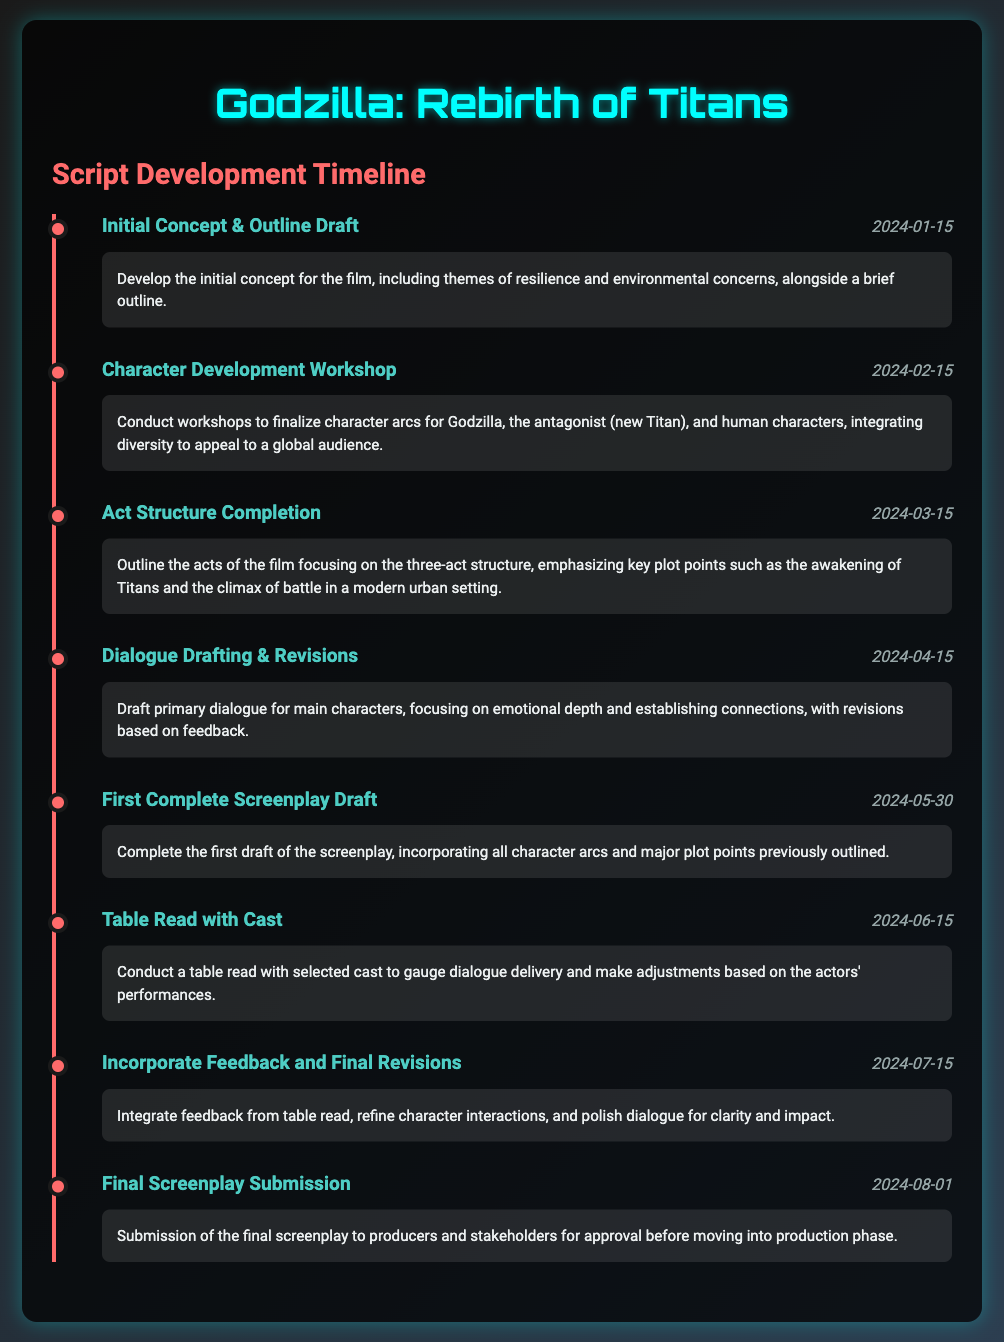what is the title of the movie? The title of the movie is presented at the top of the document.
Answer: Godzilla: Rebirth of Titans when is the Initial Concept & Outline Draft due? The date for the Initial Concept & Outline Draft is listed next to the milestone title.
Answer: 2024-01-15 what is the focus of the Character Development Workshop? The description outlines the goal of this workshop, focusing on character arcs and diversity.
Answer: Finalize character arcs what is the milestone that follows the Dialogue Drafting & Revisions? By looking at the timeline, the milestone following this is identified.
Answer: First Complete Screenplay Draft how many milestones are listed in the document? The total number of milestones can be counted from the timeline section.
Answer: eight which milestone involves a table read with the cast? The specific milestone that includes a table read is clearly named in the timeline section.
Answer: Table Read with Cast what date is the Final Screenplay Submission scheduled? This date is found next to the relevant milestone in the timeline.
Answer: 2024-08-01 what theme is incorporated into the film's initial concept? The themes are mentioned in the description of the initial milestone.
Answer: Resilience and environmental concerns what is the primary focus of the Act Structure Completion milestone? The description provides insight on what this milestone aims to achieve regarding the acts of the film.
Answer: Outline the acts of the film 